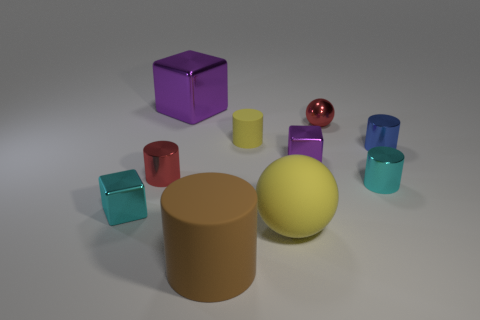What is the shape of the cyan thing that is to the right of the yellow matte thing that is behind the cyan metallic cylinder?
Give a very brief answer. Cylinder. There is a big metal block; does it have the same color as the small metal cube behind the tiny red cylinder?
Your answer should be very brief. Yes. The brown matte thing is what shape?
Your answer should be very brief. Cylinder. There is a cyan thing behind the small block to the left of the large shiny cube; what size is it?
Your answer should be very brief. Small. Are there an equal number of small cubes behind the blue object and tiny spheres right of the tiny cyan block?
Your answer should be compact. No. What material is the cylinder that is both behind the small red metal cylinder and on the left side of the tiny blue shiny thing?
Your answer should be very brief. Rubber. Does the yellow matte cylinder have the same size as the purple metal block to the right of the yellow rubber cylinder?
Make the answer very short. Yes. What number of other objects are the same color as the large cylinder?
Keep it short and to the point. 0. Are there more small things behind the cyan cube than purple cubes?
Offer a terse response. Yes. The small metallic block in front of the purple thing right of the yellow thing that is in front of the red cylinder is what color?
Your response must be concise. Cyan. 